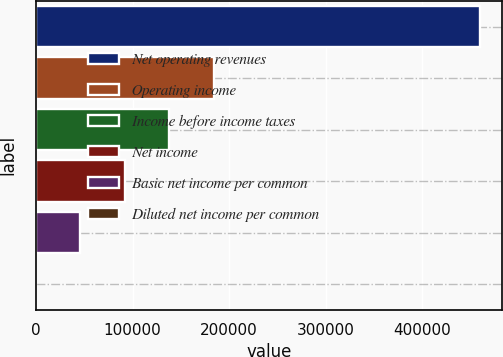Convert chart to OTSL. <chart><loc_0><loc_0><loc_500><loc_500><bar_chart><fcel>Net operating revenues<fcel>Operating income<fcel>Income before income taxes<fcel>Net income<fcel>Basic net income per common<fcel>Diluted net income per common<nl><fcel>459807<fcel>183923<fcel>137942<fcel>91961.7<fcel>45981<fcel>0.35<nl></chart> 